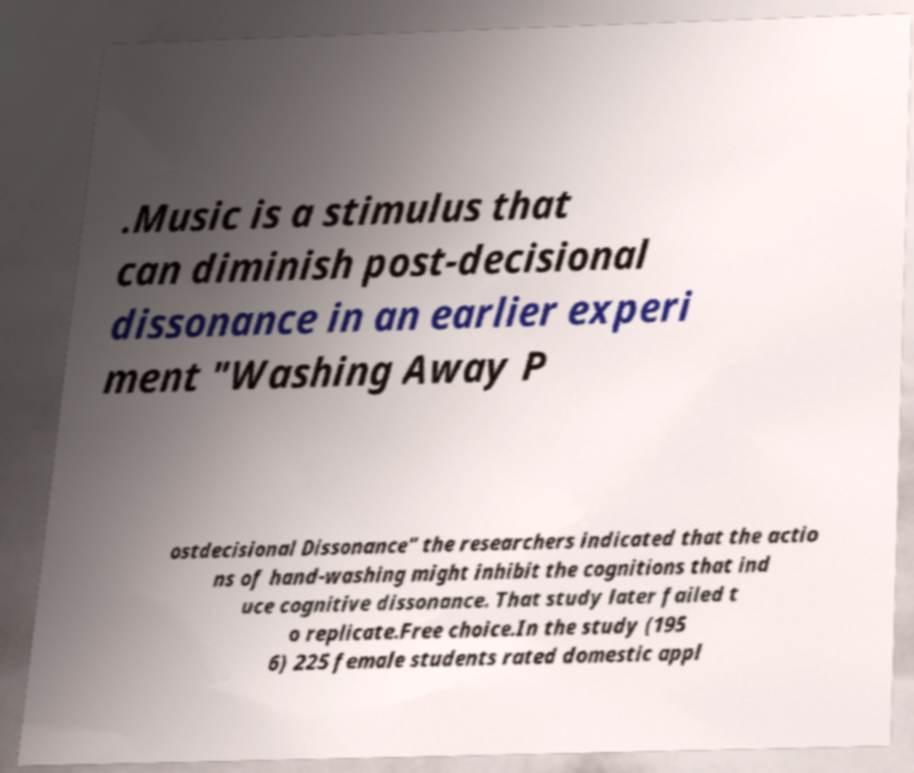Please read and relay the text visible in this image. What does it say? .Music is a stimulus that can diminish post-decisional dissonance in an earlier experi ment "Washing Away P ostdecisional Dissonance" the researchers indicated that the actio ns of hand-washing might inhibit the cognitions that ind uce cognitive dissonance. That study later failed t o replicate.Free choice.In the study (195 6) 225 female students rated domestic appl 